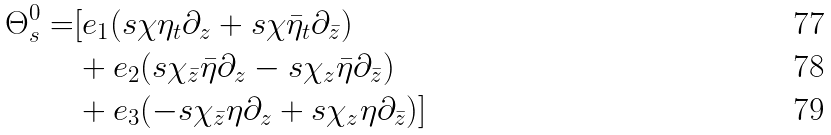<formula> <loc_0><loc_0><loc_500><loc_500>\Theta _ { s } ^ { 0 } = & [ e _ { 1 } ( s \chi \eta _ { t } \partial _ { z } + s \chi \bar { \eta } _ { t } \partial _ { \bar { z } } ) \\ & + e _ { 2 } ( s \chi _ { \bar { z } } \bar { \eta } \partial _ { z } - s \chi _ { z } \bar { \eta } \partial _ { \bar { z } } ) \\ & + e _ { 3 } ( - s \chi _ { \bar { z } } \eta \partial _ { z } + s \chi _ { z } \eta \partial _ { \bar { z } } ) ]</formula> 